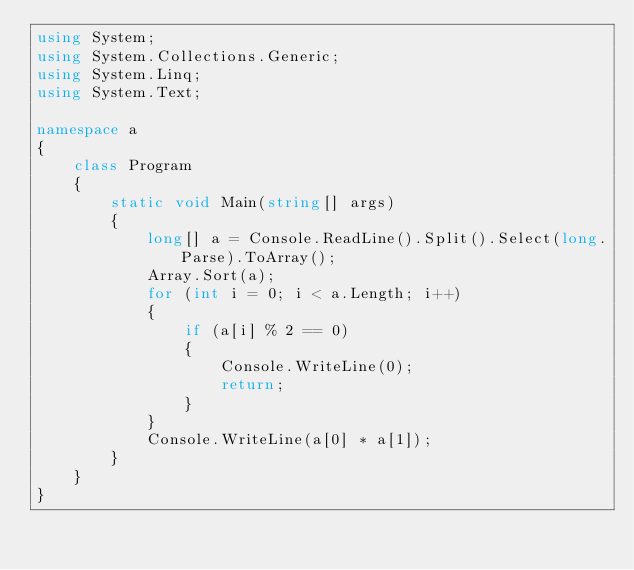Convert code to text. <code><loc_0><loc_0><loc_500><loc_500><_C#_>using System;
using System.Collections.Generic;
using System.Linq;
using System.Text;

namespace a
{
    class Program
    {
        static void Main(string[] args)
        {
            long[] a = Console.ReadLine().Split().Select(long.Parse).ToArray();
            Array.Sort(a);
            for (int i = 0; i < a.Length; i++)
            {
                if (a[i] % 2 == 0)
                {
                    Console.WriteLine(0);
                    return;
                }
            }
            Console.WriteLine(a[0] * a[1]);
        }
    }
}
</code> 